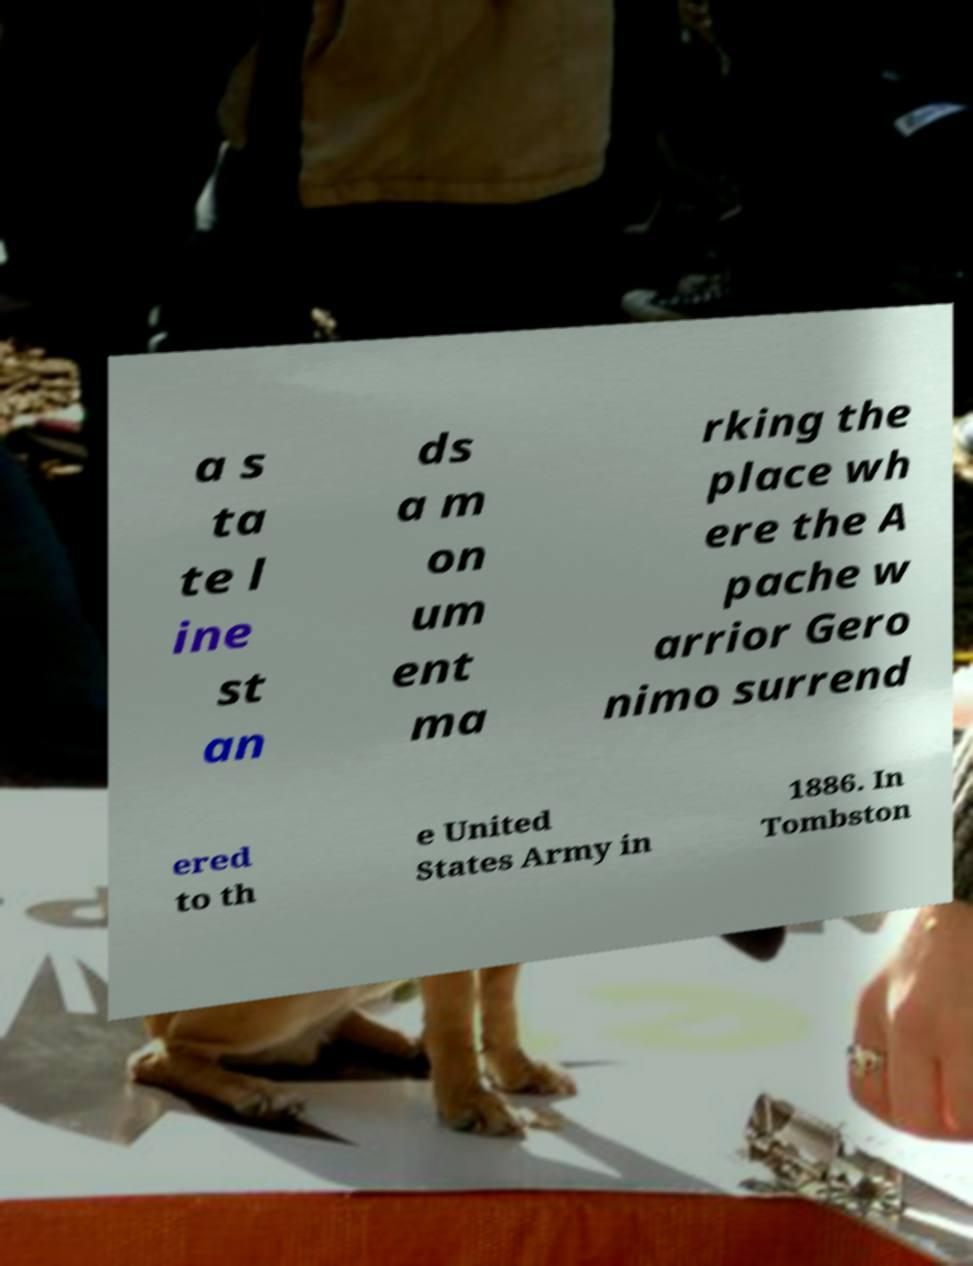For documentation purposes, I need the text within this image transcribed. Could you provide that? a s ta te l ine st an ds a m on um ent ma rking the place wh ere the A pache w arrior Gero nimo surrend ered to th e United States Army in 1886. In Tombston 